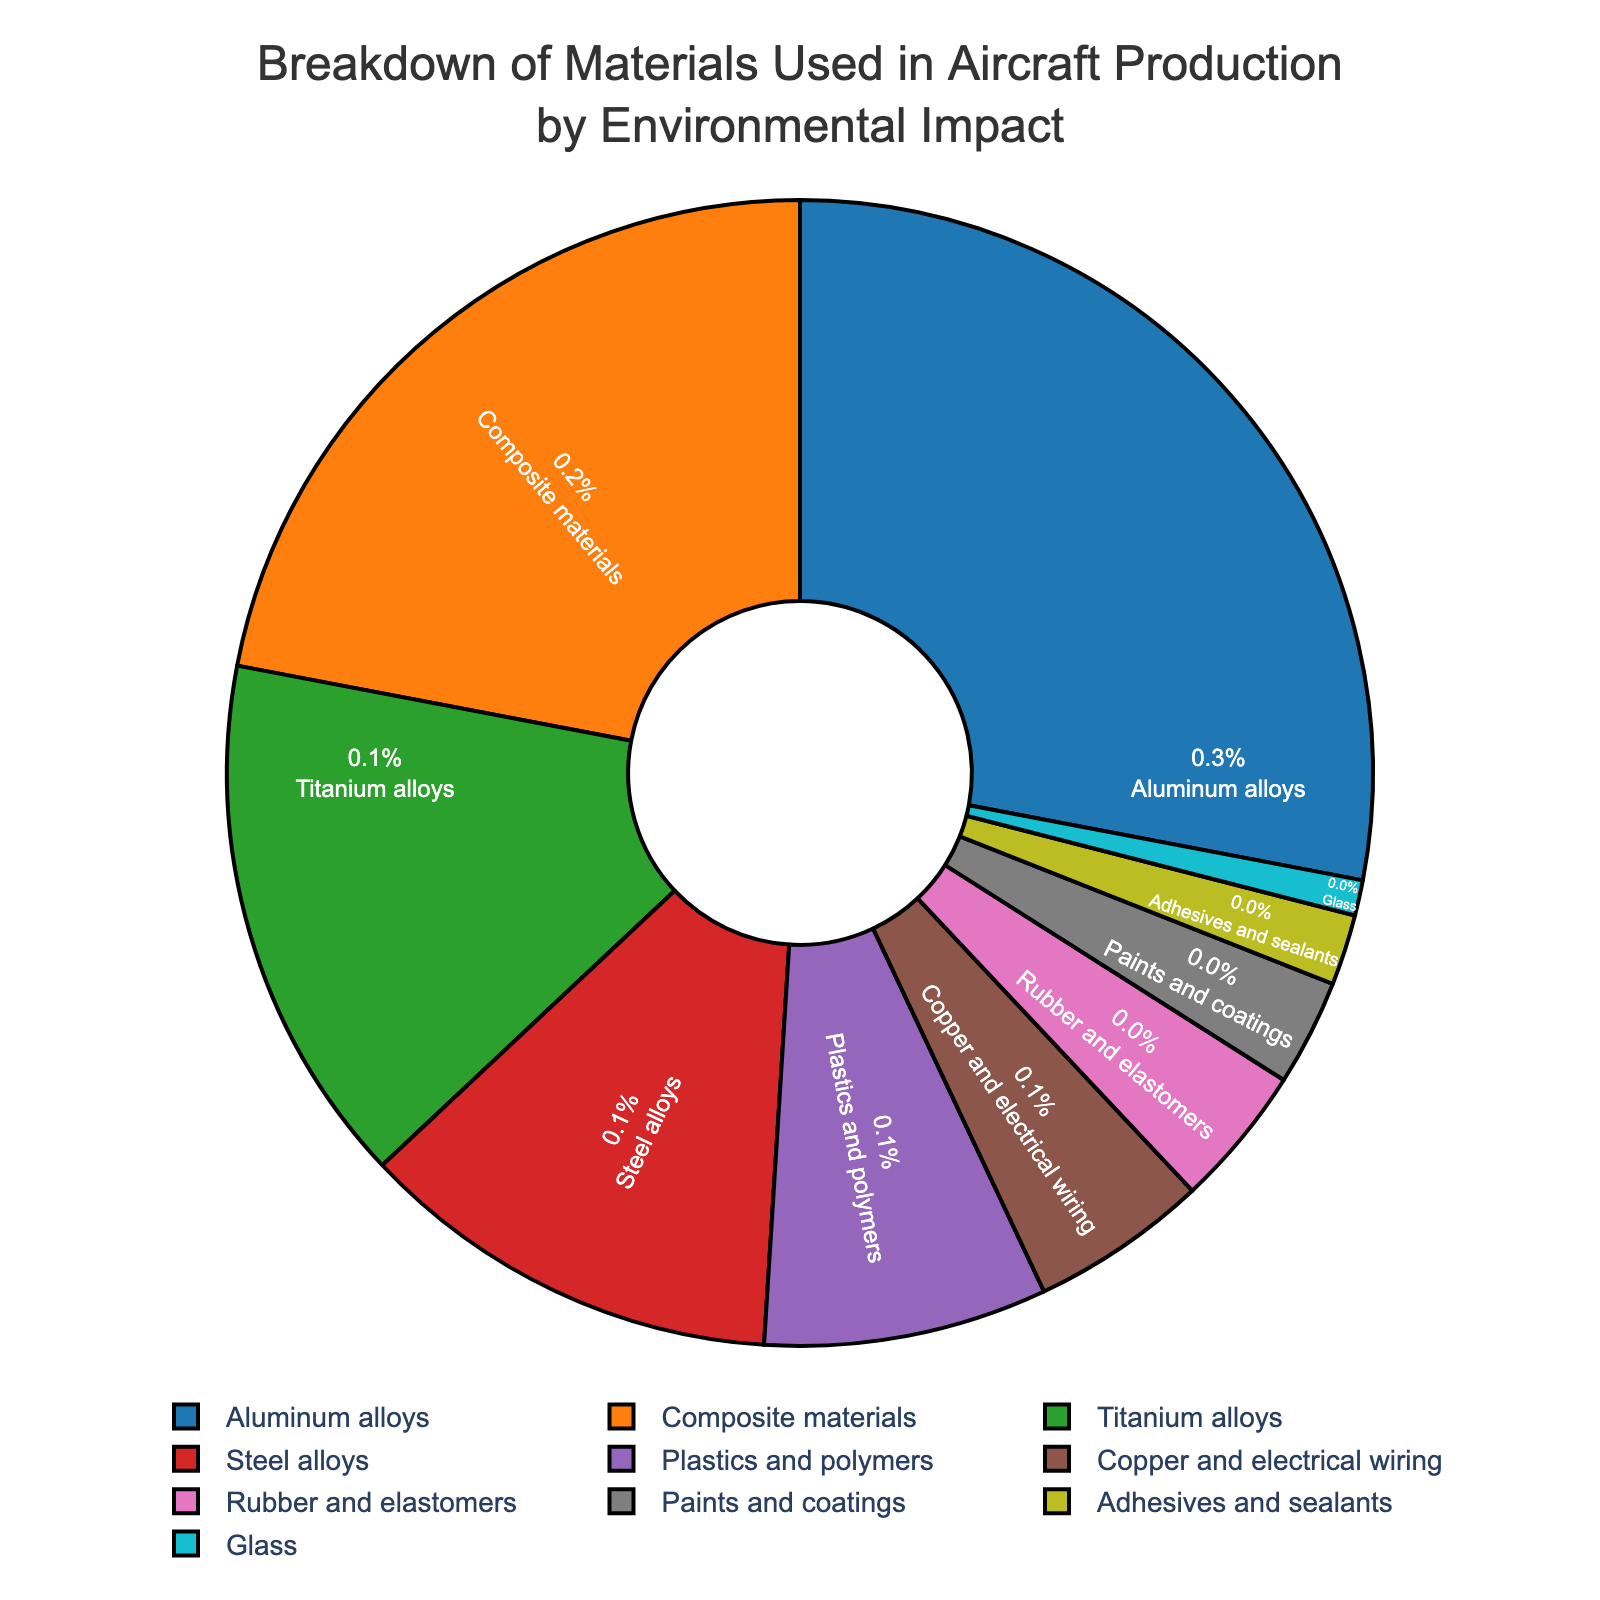What material has the highest environmental impact percentage? The figure shows the breakdown of materials with their respective environmental impact percentages. Aluminum alloys have the highest value.
Answer: Aluminum alloys Which two materials combined have the highest environmental impact percentage? Combine the top two materials with the highest percentages: Aluminum alloys (28%) and Composite materials (22%). 28% + 22% = 50%
Answer: Aluminum alloys and Composite materials Which material contributes more to the environmental impact: Titanium alloys or Steel alloys? Compare the percentages of Titanium alloys (15%) and Steel alloys (12%). Titanium alloys have a higher percentage.
Answer: Titanium alloys What’s the total environmental impact percentage for Plastics and polymers, Copper and electrical wiring, and Rubber and elastomers? Sum the percentages of these three materials: 8% + 5% + 4% = 17%
Answer: 17% By how much does the environmental impact of Aluminum alloys exceed that of Paints and coatings? Subtract the percentage of Paints and coatings (3%) from that of Aluminum alloys (28%): 28% - 3% = 25%
Answer: 25% Which material has the smallest environmental impact percentage? The figure lists the environmental impact percentages of various materials, with Glass having the smallest value at 1%.
Answer: Glass How does the environmental impact percentage of Composite materials compare to Steel alloys? Compare the percentages: Composite materials (22%) is 10% higher than Steel alloys (12%)
Answer: 10% higher If the environmental impact of Adhesives and sealants doubled, what would it be? The current impact is 2%. Doubling it results in 2% * 2 = 4%.
Answer: 4% What is the average environmental impact percentage of Titanium alloys, Steel alloys, and Plastics and polymers? Add the percentages and divide by 3: (15% + 12% + 8%) / 3 = 35% / 3 ≈ 11.67%
Answer: 11.67% Which material has an environmental impact that is exactly three times that of Glass? Glass has an impact of 1%. Three times this value is 1% * 3 = 3%. The material with this impact is Paints and coatings.
Answer: Paints and coatings 